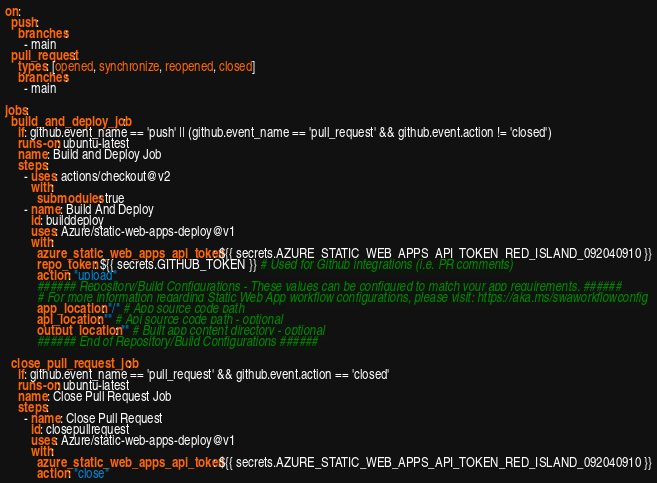<code> <loc_0><loc_0><loc_500><loc_500><_YAML_>
on:
  push:
    branches:
      - main
  pull_request:
    types: [opened, synchronize, reopened, closed]
    branches:
      - main

jobs:
  build_and_deploy_job:
    if: github.event_name == 'push' || (github.event_name == 'pull_request' && github.event.action != 'closed')
    runs-on: ubuntu-latest
    name: Build and Deploy Job
    steps:
      - uses: actions/checkout@v2
        with:
          submodules: true
      - name: Build And Deploy
        id: builddeploy
        uses: Azure/static-web-apps-deploy@v1
        with:
          azure_static_web_apps_api_token: ${{ secrets.AZURE_STATIC_WEB_APPS_API_TOKEN_RED_ISLAND_092040910 }}
          repo_token: ${{ secrets.GITHUB_TOKEN }} # Used for Github integrations (i.e. PR comments)
          action: "upload"
          ###### Repository/Build Configurations - These values can be configured to match your app requirements. ######
          # For more information regarding Static Web App workflow configurations, please visit: https://aka.ms/swaworkflowconfig
          app_location: "/" # App source code path
          api_location: "" # Api source code path - optional
          output_location: "" # Built app content directory - optional
          ###### End of Repository/Build Configurations ######

  close_pull_request_job:
    if: github.event_name == 'pull_request' && github.event.action == 'closed'
    runs-on: ubuntu-latest
    name: Close Pull Request Job
    steps:
      - name: Close Pull Request
        id: closepullrequest
        uses: Azure/static-web-apps-deploy@v1
        with:
          azure_static_web_apps_api_token: ${{ secrets.AZURE_STATIC_WEB_APPS_API_TOKEN_RED_ISLAND_092040910 }}
          action: "close"
</code> 